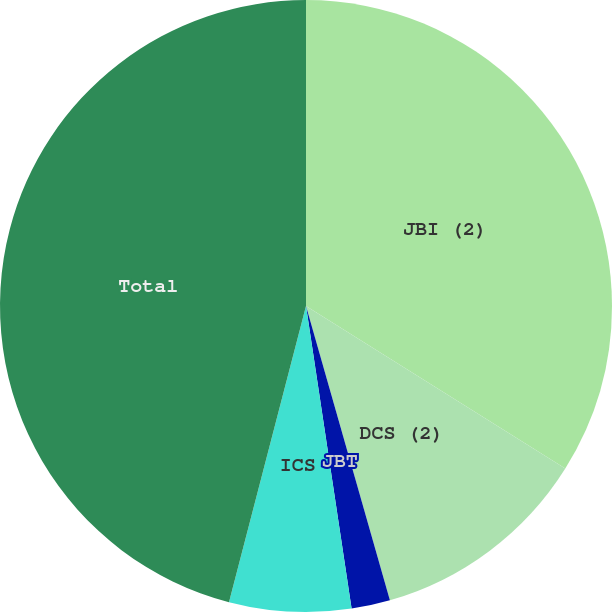<chart> <loc_0><loc_0><loc_500><loc_500><pie_chart><fcel>JBI (2)<fcel>DCS (2)<fcel>JBT<fcel>ICS<fcel>Total<nl><fcel>33.91%<fcel>11.67%<fcel>2.04%<fcel>6.43%<fcel>45.95%<nl></chart> 